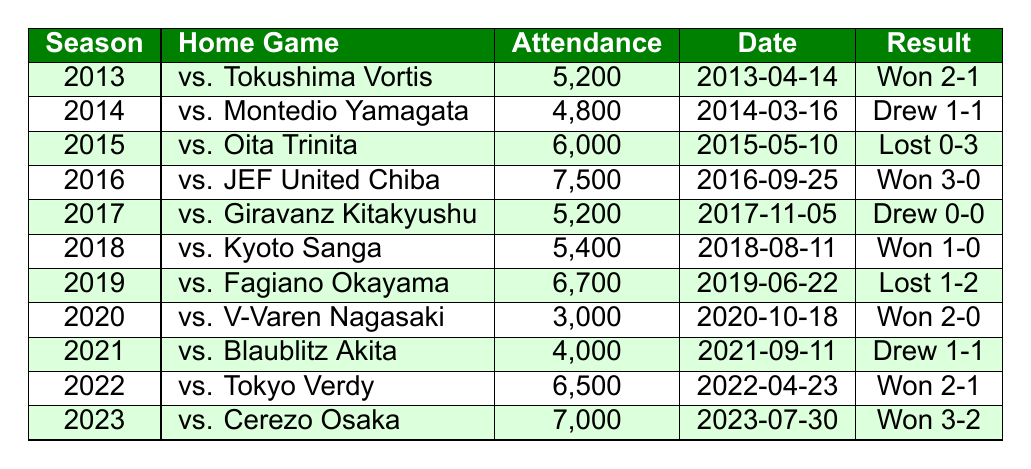What was the highest attendance at a Mito HollyHock home game in the given seasons? By looking through the table, the highest recorded attendance is 7,500 during the match against JEF United Chiba in the 2016 season.
Answer: 7,500 Which home game in 2023 had the highest attendance? In the 2023 season, the match against Cerezo Osaka had an attendance of 7,000, which is the attendance for that year.
Answer: 7,000 How many home games had an attendance of more than 6,000? The seasons with more than 6,000 attendance are 2015 (6,000), 2016 (7,500), 2019 (6,700), 2022 (6,500), and 2023 (7,000). Thus, there are 5 home games that meet this criterion.
Answer: 5 What was the average attendance across all seasons? The total attendance can be calculated by adding all attendance values (5,200 + 4,800 + 6,000 + 7,500 + 5,200 + 5,400 + 6,700 + 3,000 + 4,000 + 6,500 + 7,000 = 58,300), and since there are 11 seasons, the average is 58,300 / 11 ≈ 5,300.
Answer: 5,300 Was there any season where Mito HollyHock ended the home game with a draw and had an attendance of less than 5,500? Yes, the season 2014 had a game that ended in a draw (1-1) with an attendance of 4,800, which is less than 5,500.
Answer: Yes Which two years had the same attendance of 5,200? Both the 2013 and 2017 seasons had an identical attendance of 5,200 during their respective home games.
Answer: 2013 and 2017 Did Mito HollyHock have more home games with wins or losses based on the given data? Counting the results, there are 6 wins (2013, 2016, 2018, 2020, 2022, 2023), 3 losses (2015, 2019), and 2 draws (2014, 2021). Therefore, they had more wins than losses.
Answer: Yes, more wins What is the difference in attendance between the highest and lowest recorded home game? The highest attendance is 7,500 (2016) and the lowest is 3,000 (2020). The difference is 7,500 - 3,000 = 4,500.
Answer: 4,500 How many games did Mito HollyHock win in the period from 2013 to 2020? From the table, the home games won in that period are in the seasons 2013, 2016, and 2020, adding up to a total of 3 wins within that range.
Answer: 3 